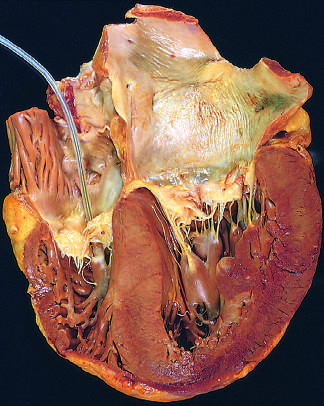what is presented incidentally in the right ventricle?
Answer the question using a single word or phrase. A pacemaker 